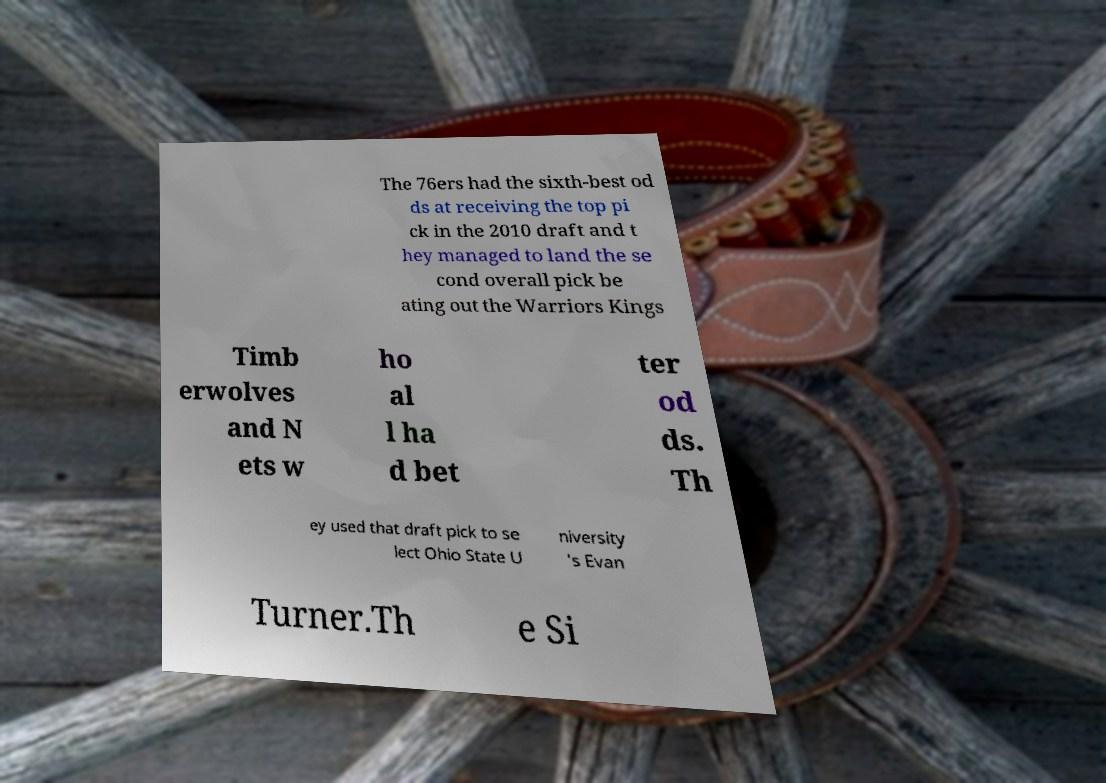What messages or text are displayed in this image? I need them in a readable, typed format. The 76ers had the sixth-best od ds at receiving the top pi ck in the 2010 draft and t hey managed to land the se cond overall pick be ating out the Warriors Kings Timb erwolves and N ets w ho al l ha d bet ter od ds. Th ey used that draft pick to se lect Ohio State U niversity 's Evan Turner.Th e Si 